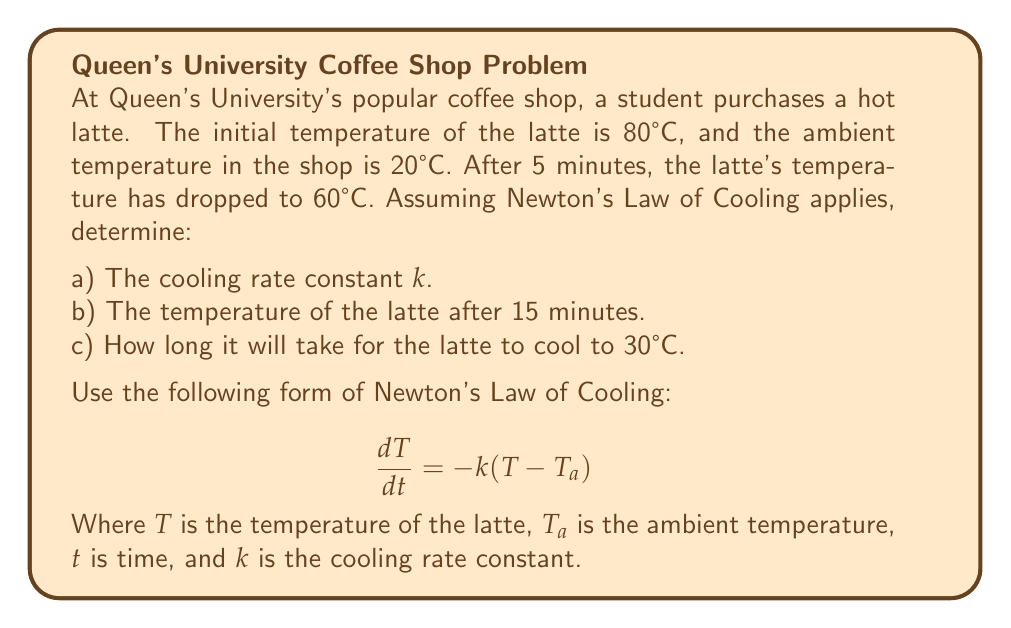Give your solution to this math problem. Let's solve this problem step by step:

1) Newton's Law of Cooling in its integrated form is:

   $$T(t) = T_a + (T_0 - T_a)e^{-kt}$$

   Where $T(t)$ is the temperature at time t, $T_a$ is the ambient temperature, $T_0$ is the initial temperature, and k is the cooling rate constant.

a) To find k:
   
   We know $T_0 = 80°C$, $T_a = 20°C$, $T(5) = 60°C$
   
   Plugging into the equation:
   
   $$60 = 20 + (80 - 20)e^{-5k}$$
   $$40 = 60e^{-5k}$$
   $$\frac{2}{3} = e^{-5k}$$
   $$\ln(\frac{2}{3}) = -5k$$
   $$k = -\frac{1}{5}\ln(\frac{2}{3}) \approx 0.0811 \text{ min}^{-1}$$

b) For the temperature after 15 minutes:
   
   $$T(15) = 20 + (80 - 20)e^{-0.0811 \times 15} \approx 38.7°C$$

c) To find when the latte reaches 30°C:
   
   $$30 = 20 + (80 - 20)e^{-0.0811t}$$
   $$\frac{10}{60} = e^{-0.0811t}$$
   $$\ln(\frac{1}{6}) = -0.0811t$$
   $$t = -\frac{1}{0.0811}\ln(\frac{1}{6}) \approx 22.1 \text{ minutes}$$
Answer: a) $k \approx 0.0811 \text{ min}^{-1}$
b) $T(15) \approx 38.7°C$
c) $t \approx 22.1 \text{ minutes}$ 